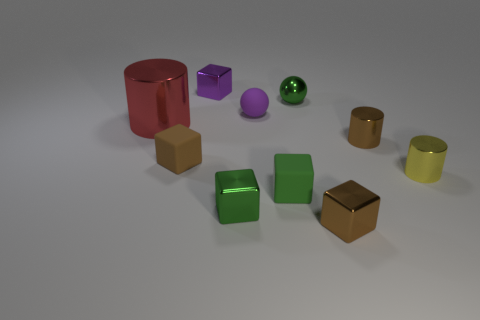Subtract all yellow cylinders. How many cylinders are left? 2 Subtract all brown cylinders. How many cylinders are left? 2 Subtract all spheres. How many objects are left? 8 Subtract all brown spheres. Subtract all cyan cylinders. How many spheres are left? 2 Add 9 tiny red metallic things. How many tiny red metallic things exist? 9 Subtract 0 cyan spheres. How many objects are left? 10 Subtract 1 cylinders. How many cylinders are left? 2 Subtract all red cylinders. How many red balls are left? 0 Subtract all big red shiny things. Subtract all tiny rubber things. How many objects are left? 6 Add 2 green things. How many green things are left? 5 